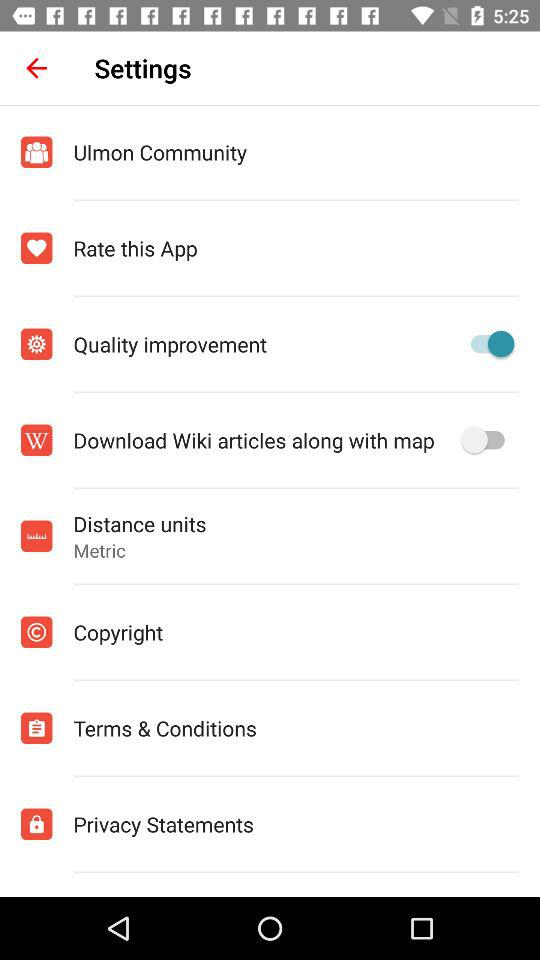What is the setting for distance units? The setting for distance units is "Metric". 